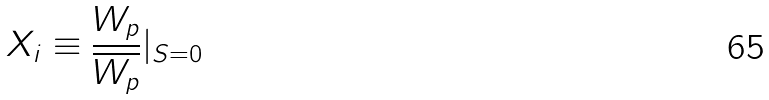Convert formula to latex. <formula><loc_0><loc_0><loc_500><loc_500>X _ { i } \equiv \frac { W _ { p } } { \overline { W _ { p } } } | _ { S = 0 }</formula> 